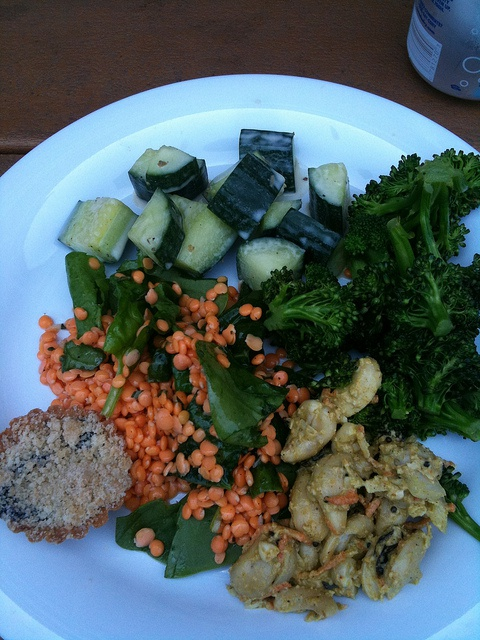Describe the objects in this image and their specific colors. I can see dining table in black and gray tones and broccoli in black, darkgreen, and teal tones in this image. 